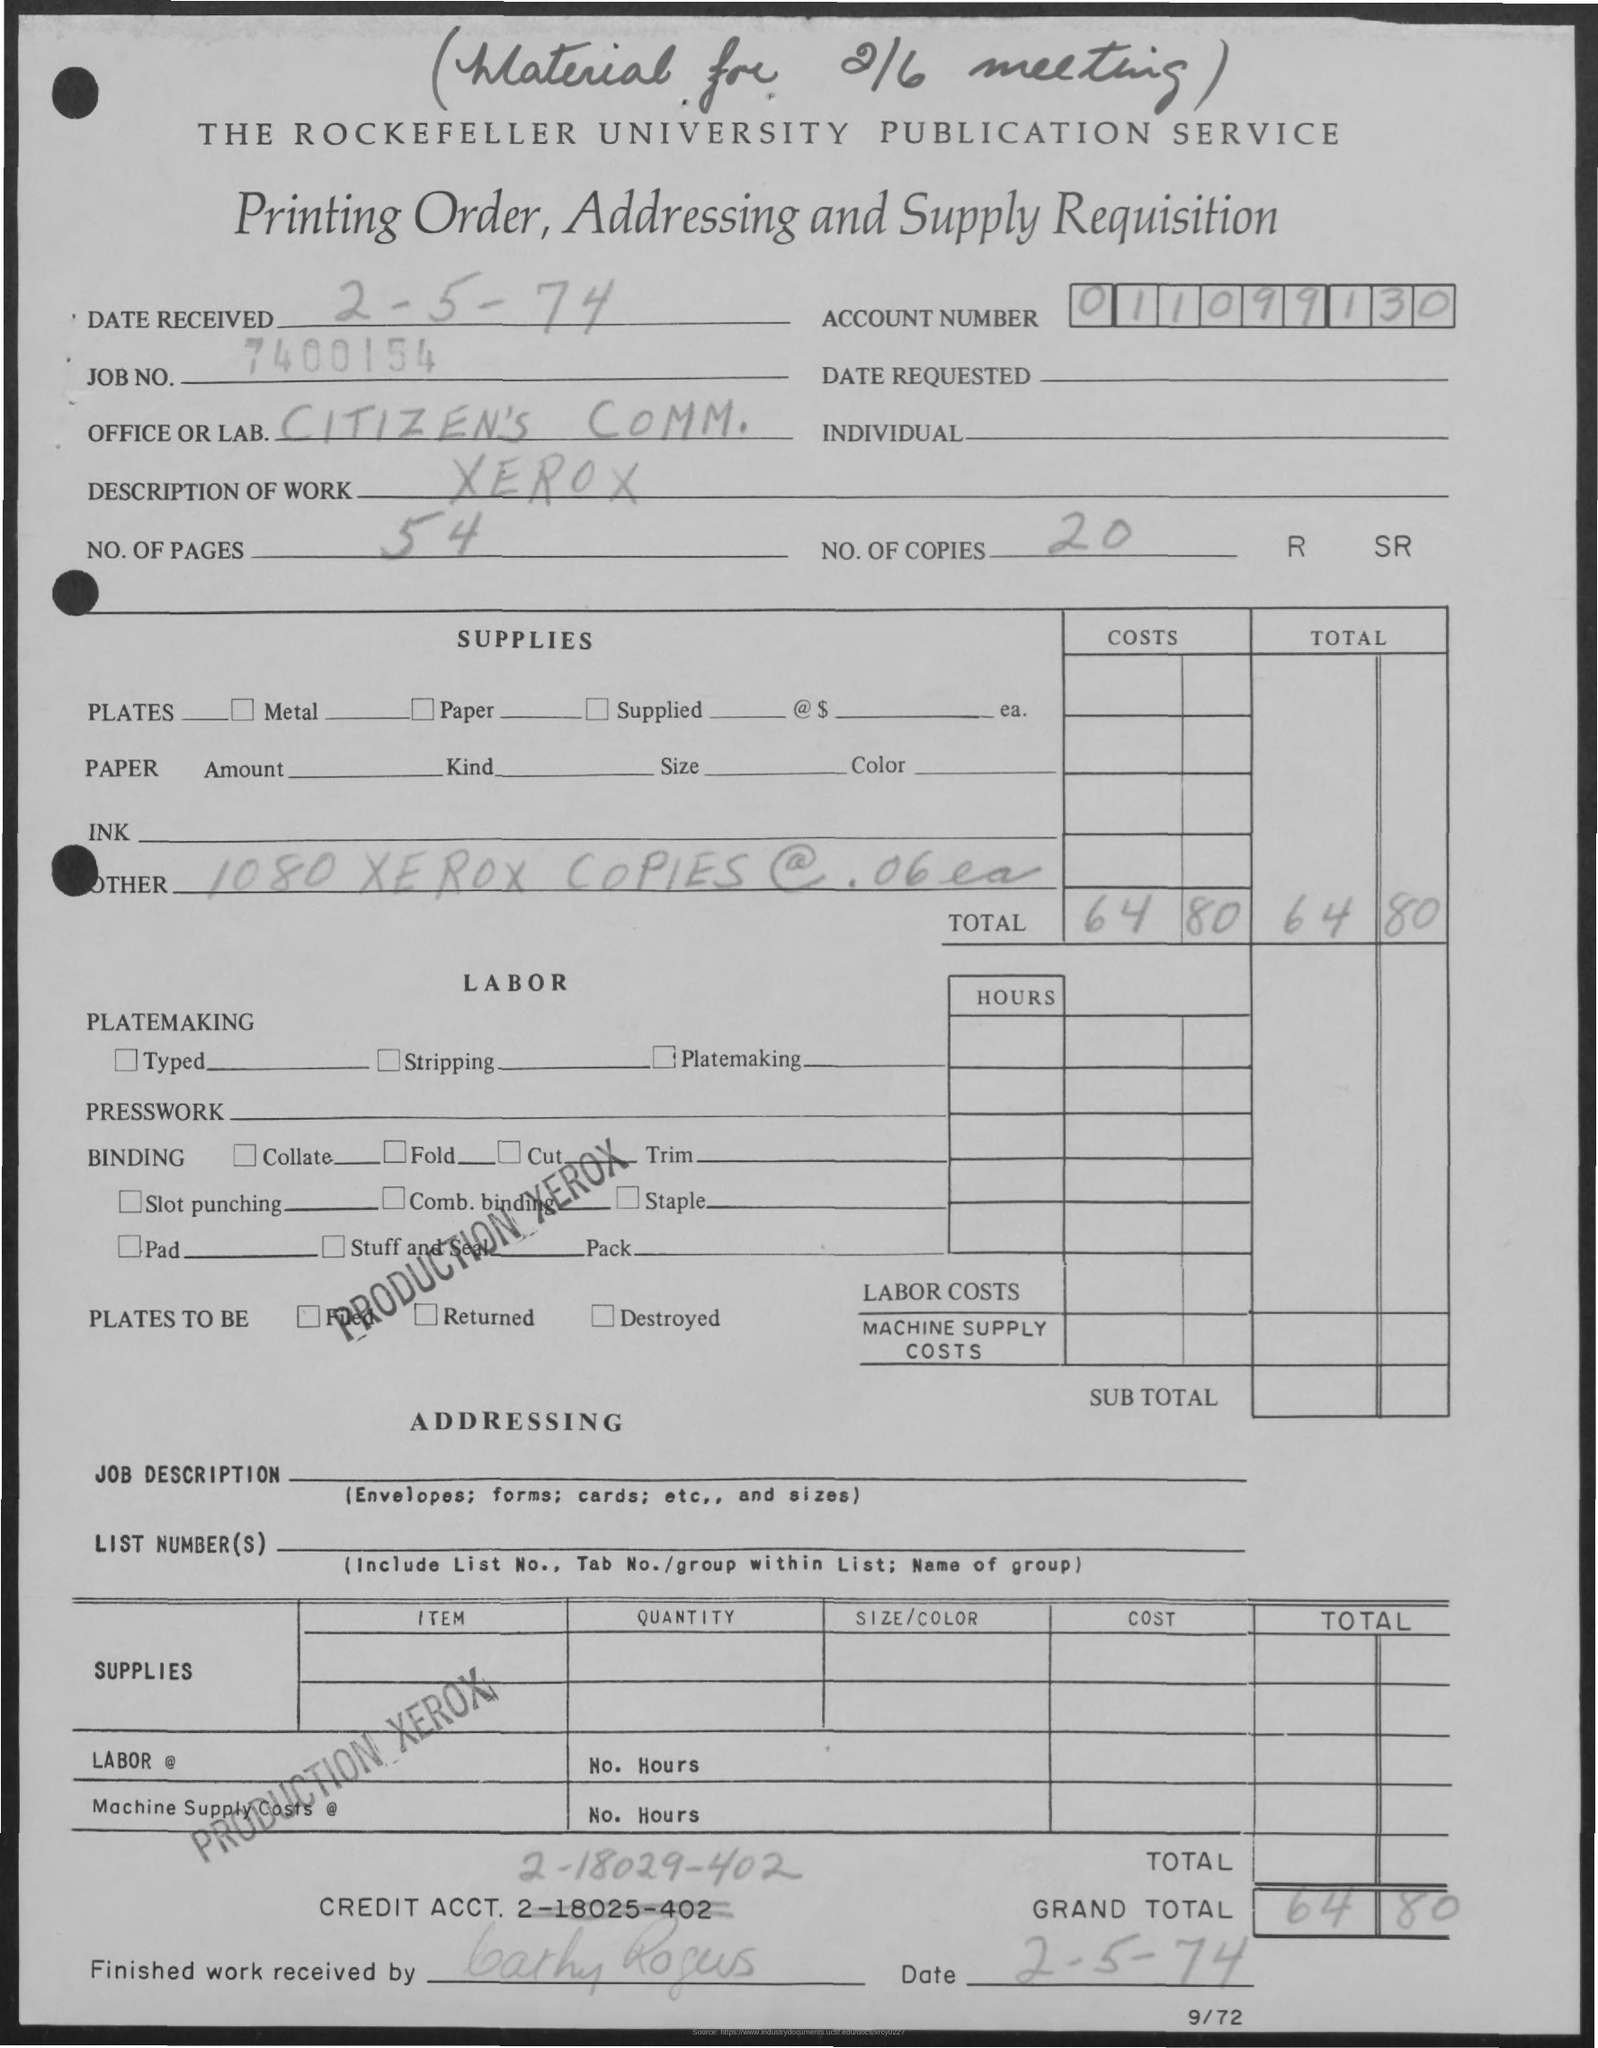Draw attention to some important aspects in this diagram. Your credit account number is 2-18029-402. The grand total is 64.80. What is the account number? It is 011099130...". The number of copies is 20. The number of pages is 54. 